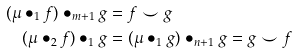Convert formula to latex. <formula><loc_0><loc_0><loc_500><loc_500>( \mu \bullet _ { 1 } f ) \bullet _ { m + 1 } g & = f \smile g \\ ( \mu \bullet _ { 2 } f ) \bullet _ { 1 } g & = ( \mu \bullet _ { 1 } g ) \bullet _ { n + 1 } g = g \smile f</formula> 